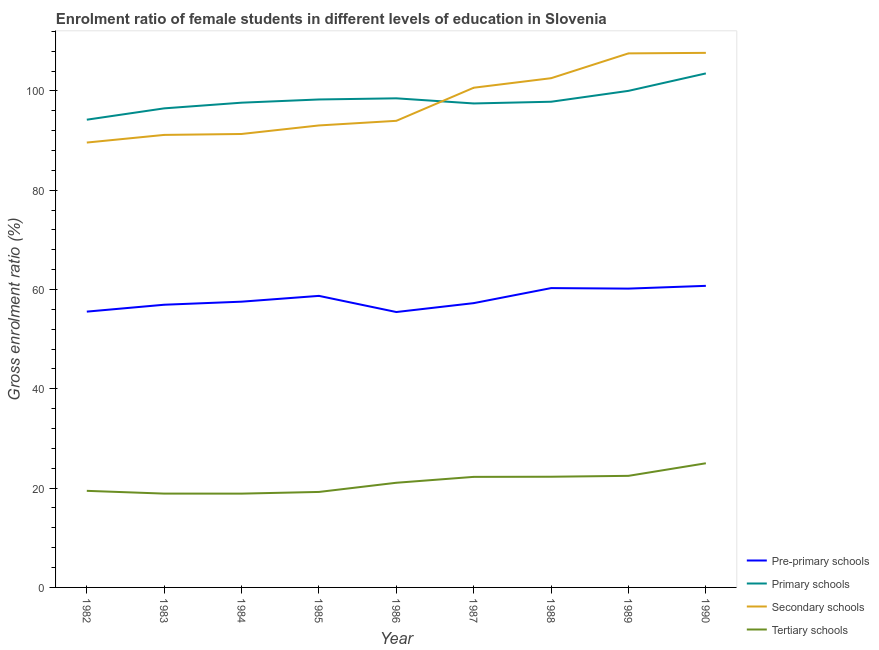Does the line corresponding to gross enrolment ratio(male) in secondary schools intersect with the line corresponding to gross enrolment ratio(male) in pre-primary schools?
Keep it short and to the point. No. What is the gross enrolment ratio(male) in secondary schools in 1986?
Your answer should be very brief. 93.98. Across all years, what is the maximum gross enrolment ratio(male) in pre-primary schools?
Your answer should be very brief. 60.74. Across all years, what is the minimum gross enrolment ratio(male) in secondary schools?
Keep it short and to the point. 89.61. In which year was the gross enrolment ratio(male) in pre-primary schools minimum?
Keep it short and to the point. 1986. What is the total gross enrolment ratio(male) in primary schools in the graph?
Provide a succinct answer. 884.01. What is the difference between the gross enrolment ratio(male) in pre-primary schools in 1987 and that in 1990?
Make the answer very short. -3.48. What is the difference between the gross enrolment ratio(male) in secondary schools in 1984 and the gross enrolment ratio(male) in pre-primary schools in 1986?
Provide a succinct answer. 35.86. What is the average gross enrolment ratio(male) in primary schools per year?
Your answer should be compact. 98.22. In the year 1987, what is the difference between the gross enrolment ratio(male) in tertiary schools and gross enrolment ratio(male) in primary schools?
Give a very brief answer. -75.21. In how many years, is the gross enrolment ratio(male) in primary schools greater than 104 %?
Ensure brevity in your answer.  0. What is the ratio of the gross enrolment ratio(male) in secondary schools in 1982 to that in 1984?
Your answer should be very brief. 0.98. What is the difference between the highest and the second highest gross enrolment ratio(male) in pre-primary schools?
Offer a very short reply. 0.45. What is the difference between the highest and the lowest gross enrolment ratio(male) in primary schools?
Your answer should be compact. 9.32. In how many years, is the gross enrolment ratio(male) in tertiary schools greater than the average gross enrolment ratio(male) in tertiary schools taken over all years?
Offer a very short reply. 5. Is the gross enrolment ratio(male) in tertiary schools strictly greater than the gross enrolment ratio(male) in primary schools over the years?
Make the answer very short. No. How many lines are there?
Provide a short and direct response. 4. What is the difference between two consecutive major ticks on the Y-axis?
Provide a short and direct response. 20. Does the graph contain grids?
Offer a terse response. No. How many legend labels are there?
Your response must be concise. 4. How are the legend labels stacked?
Keep it short and to the point. Vertical. What is the title of the graph?
Your answer should be compact. Enrolment ratio of female students in different levels of education in Slovenia. What is the label or title of the X-axis?
Provide a short and direct response. Year. What is the label or title of the Y-axis?
Offer a very short reply. Gross enrolment ratio (%). What is the Gross enrolment ratio (%) in Pre-primary schools in 1982?
Your response must be concise. 55.55. What is the Gross enrolment ratio (%) in Primary schools in 1982?
Offer a very short reply. 94.21. What is the Gross enrolment ratio (%) of Secondary schools in 1982?
Provide a succinct answer. 89.61. What is the Gross enrolment ratio (%) in Tertiary schools in 1982?
Offer a terse response. 19.45. What is the Gross enrolment ratio (%) in Pre-primary schools in 1983?
Offer a terse response. 56.94. What is the Gross enrolment ratio (%) of Primary schools in 1983?
Your answer should be very brief. 96.49. What is the Gross enrolment ratio (%) in Secondary schools in 1983?
Offer a terse response. 91.15. What is the Gross enrolment ratio (%) in Tertiary schools in 1983?
Keep it short and to the point. 18.9. What is the Gross enrolment ratio (%) in Pre-primary schools in 1984?
Your response must be concise. 57.56. What is the Gross enrolment ratio (%) in Primary schools in 1984?
Provide a short and direct response. 97.64. What is the Gross enrolment ratio (%) in Secondary schools in 1984?
Ensure brevity in your answer.  91.33. What is the Gross enrolment ratio (%) of Tertiary schools in 1984?
Offer a terse response. 18.89. What is the Gross enrolment ratio (%) of Pre-primary schools in 1985?
Offer a very short reply. 58.72. What is the Gross enrolment ratio (%) of Primary schools in 1985?
Offer a very short reply. 98.28. What is the Gross enrolment ratio (%) of Secondary schools in 1985?
Give a very brief answer. 93.05. What is the Gross enrolment ratio (%) of Tertiary schools in 1985?
Offer a very short reply. 19.23. What is the Gross enrolment ratio (%) of Pre-primary schools in 1986?
Keep it short and to the point. 55.47. What is the Gross enrolment ratio (%) of Primary schools in 1986?
Ensure brevity in your answer.  98.52. What is the Gross enrolment ratio (%) of Secondary schools in 1986?
Offer a terse response. 93.98. What is the Gross enrolment ratio (%) of Tertiary schools in 1986?
Offer a terse response. 21.08. What is the Gross enrolment ratio (%) in Pre-primary schools in 1987?
Your response must be concise. 57.26. What is the Gross enrolment ratio (%) in Primary schools in 1987?
Give a very brief answer. 97.48. What is the Gross enrolment ratio (%) of Secondary schools in 1987?
Give a very brief answer. 100.65. What is the Gross enrolment ratio (%) of Tertiary schools in 1987?
Make the answer very short. 22.27. What is the Gross enrolment ratio (%) of Pre-primary schools in 1988?
Your answer should be very brief. 60.29. What is the Gross enrolment ratio (%) in Primary schools in 1988?
Keep it short and to the point. 97.83. What is the Gross enrolment ratio (%) in Secondary schools in 1988?
Your response must be concise. 102.57. What is the Gross enrolment ratio (%) in Tertiary schools in 1988?
Your answer should be compact. 22.29. What is the Gross enrolment ratio (%) of Pre-primary schools in 1989?
Offer a very short reply. 60.19. What is the Gross enrolment ratio (%) in Primary schools in 1989?
Your answer should be compact. 100.02. What is the Gross enrolment ratio (%) in Secondary schools in 1989?
Your answer should be compact. 107.57. What is the Gross enrolment ratio (%) in Tertiary schools in 1989?
Offer a very short reply. 22.48. What is the Gross enrolment ratio (%) in Pre-primary schools in 1990?
Ensure brevity in your answer.  60.74. What is the Gross enrolment ratio (%) of Primary schools in 1990?
Ensure brevity in your answer.  103.53. What is the Gross enrolment ratio (%) in Secondary schools in 1990?
Give a very brief answer. 107.67. What is the Gross enrolment ratio (%) of Tertiary schools in 1990?
Give a very brief answer. 25.01. Across all years, what is the maximum Gross enrolment ratio (%) in Pre-primary schools?
Offer a terse response. 60.74. Across all years, what is the maximum Gross enrolment ratio (%) in Primary schools?
Offer a terse response. 103.53. Across all years, what is the maximum Gross enrolment ratio (%) in Secondary schools?
Provide a short and direct response. 107.67. Across all years, what is the maximum Gross enrolment ratio (%) in Tertiary schools?
Offer a very short reply. 25.01. Across all years, what is the minimum Gross enrolment ratio (%) of Pre-primary schools?
Your answer should be very brief. 55.47. Across all years, what is the minimum Gross enrolment ratio (%) of Primary schools?
Your answer should be very brief. 94.21. Across all years, what is the minimum Gross enrolment ratio (%) of Secondary schools?
Offer a very short reply. 89.61. Across all years, what is the minimum Gross enrolment ratio (%) in Tertiary schools?
Offer a terse response. 18.89. What is the total Gross enrolment ratio (%) of Pre-primary schools in the graph?
Ensure brevity in your answer.  522.73. What is the total Gross enrolment ratio (%) in Primary schools in the graph?
Your response must be concise. 884.01. What is the total Gross enrolment ratio (%) of Secondary schools in the graph?
Keep it short and to the point. 877.59. What is the total Gross enrolment ratio (%) in Tertiary schools in the graph?
Provide a succinct answer. 189.61. What is the difference between the Gross enrolment ratio (%) in Pre-primary schools in 1982 and that in 1983?
Keep it short and to the point. -1.39. What is the difference between the Gross enrolment ratio (%) of Primary schools in 1982 and that in 1983?
Keep it short and to the point. -2.28. What is the difference between the Gross enrolment ratio (%) of Secondary schools in 1982 and that in 1983?
Offer a very short reply. -1.54. What is the difference between the Gross enrolment ratio (%) in Tertiary schools in 1982 and that in 1983?
Ensure brevity in your answer.  0.56. What is the difference between the Gross enrolment ratio (%) of Pre-primary schools in 1982 and that in 1984?
Offer a terse response. -2. What is the difference between the Gross enrolment ratio (%) of Primary schools in 1982 and that in 1984?
Provide a succinct answer. -3.43. What is the difference between the Gross enrolment ratio (%) of Secondary schools in 1982 and that in 1984?
Your answer should be compact. -1.73. What is the difference between the Gross enrolment ratio (%) of Tertiary schools in 1982 and that in 1984?
Provide a succinct answer. 0.56. What is the difference between the Gross enrolment ratio (%) in Pre-primary schools in 1982 and that in 1985?
Provide a succinct answer. -3.17. What is the difference between the Gross enrolment ratio (%) in Primary schools in 1982 and that in 1985?
Your answer should be compact. -4.07. What is the difference between the Gross enrolment ratio (%) of Secondary schools in 1982 and that in 1985?
Ensure brevity in your answer.  -3.45. What is the difference between the Gross enrolment ratio (%) of Tertiary schools in 1982 and that in 1985?
Your response must be concise. 0.22. What is the difference between the Gross enrolment ratio (%) in Pre-primary schools in 1982 and that in 1986?
Make the answer very short. 0.08. What is the difference between the Gross enrolment ratio (%) of Primary schools in 1982 and that in 1986?
Your answer should be very brief. -4.3. What is the difference between the Gross enrolment ratio (%) in Secondary schools in 1982 and that in 1986?
Ensure brevity in your answer.  -4.38. What is the difference between the Gross enrolment ratio (%) of Tertiary schools in 1982 and that in 1986?
Make the answer very short. -1.63. What is the difference between the Gross enrolment ratio (%) in Pre-primary schools in 1982 and that in 1987?
Keep it short and to the point. -1.71. What is the difference between the Gross enrolment ratio (%) in Primary schools in 1982 and that in 1987?
Offer a very short reply. -3.27. What is the difference between the Gross enrolment ratio (%) of Secondary schools in 1982 and that in 1987?
Your answer should be very brief. -11.04. What is the difference between the Gross enrolment ratio (%) of Tertiary schools in 1982 and that in 1987?
Make the answer very short. -2.82. What is the difference between the Gross enrolment ratio (%) in Pre-primary schools in 1982 and that in 1988?
Your response must be concise. -4.74. What is the difference between the Gross enrolment ratio (%) of Primary schools in 1982 and that in 1988?
Keep it short and to the point. -3.62. What is the difference between the Gross enrolment ratio (%) of Secondary schools in 1982 and that in 1988?
Your response must be concise. -12.96. What is the difference between the Gross enrolment ratio (%) in Tertiary schools in 1982 and that in 1988?
Your response must be concise. -2.84. What is the difference between the Gross enrolment ratio (%) in Pre-primary schools in 1982 and that in 1989?
Provide a succinct answer. -4.63. What is the difference between the Gross enrolment ratio (%) in Primary schools in 1982 and that in 1989?
Offer a terse response. -5.81. What is the difference between the Gross enrolment ratio (%) in Secondary schools in 1982 and that in 1989?
Ensure brevity in your answer.  -17.96. What is the difference between the Gross enrolment ratio (%) of Tertiary schools in 1982 and that in 1989?
Your answer should be compact. -3.02. What is the difference between the Gross enrolment ratio (%) of Pre-primary schools in 1982 and that in 1990?
Provide a short and direct response. -5.19. What is the difference between the Gross enrolment ratio (%) of Primary schools in 1982 and that in 1990?
Provide a short and direct response. -9.32. What is the difference between the Gross enrolment ratio (%) of Secondary schools in 1982 and that in 1990?
Your response must be concise. -18.07. What is the difference between the Gross enrolment ratio (%) of Tertiary schools in 1982 and that in 1990?
Offer a very short reply. -5.56. What is the difference between the Gross enrolment ratio (%) of Pre-primary schools in 1983 and that in 1984?
Make the answer very short. -0.62. What is the difference between the Gross enrolment ratio (%) in Primary schools in 1983 and that in 1984?
Your answer should be very brief. -1.14. What is the difference between the Gross enrolment ratio (%) of Secondary schools in 1983 and that in 1984?
Ensure brevity in your answer.  -0.19. What is the difference between the Gross enrolment ratio (%) in Tertiary schools in 1983 and that in 1984?
Give a very brief answer. 0. What is the difference between the Gross enrolment ratio (%) of Pre-primary schools in 1983 and that in 1985?
Keep it short and to the point. -1.78. What is the difference between the Gross enrolment ratio (%) in Primary schools in 1983 and that in 1985?
Make the answer very short. -1.79. What is the difference between the Gross enrolment ratio (%) in Secondary schools in 1983 and that in 1985?
Your answer should be very brief. -1.91. What is the difference between the Gross enrolment ratio (%) of Tertiary schools in 1983 and that in 1985?
Make the answer very short. -0.33. What is the difference between the Gross enrolment ratio (%) in Pre-primary schools in 1983 and that in 1986?
Provide a succinct answer. 1.47. What is the difference between the Gross enrolment ratio (%) in Primary schools in 1983 and that in 1986?
Make the answer very short. -2.02. What is the difference between the Gross enrolment ratio (%) of Secondary schools in 1983 and that in 1986?
Offer a very short reply. -2.84. What is the difference between the Gross enrolment ratio (%) in Tertiary schools in 1983 and that in 1986?
Give a very brief answer. -2.18. What is the difference between the Gross enrolment ratio (%) of Pre-primary schools in 1983 and that in 1987?
Give a very brief answer. -0.32. What is the difference between the Gross enrolment ratio (%) in Primary schools in 1983 and that in 1987?
Your answer should be very brief. -0.99. What is the difference between the Gross enrolment ratio (%) of Secondary schools in 1983 and that in 1987?
Your answer should be very brief. -9.5. What is the difference between the Gross enrolment ratio (%) of Tertiary schools in 1983 and that in 1987?
Offer a terse response. -3.37. What is the difference between the Gross enrolment ratio (%) of Pre-primary schools in 1983 and that in 1988?
Ensure brevity in your answer.  -3.35. What is the difference between the Gross enrolment ratio (%) of Primary schools in 1983 and that in 1988?
Provide a short and direct response. -1.33. What is the difference between the Gross enrolment ratio (%) in Secondary schools in 1983 and that in 1988?
Ensure brevity in your answer.  -11.42. What is the difference between the Gross enrolment ratio (%) of Tertiary schools in 1983 and that in 1988?
Provide a short and direct response. -3.4. What is the difference between the Gross enrolment ratio (%) in Pre-primary schools in 1983 and that in 1989?
Provide a short and direct response. -3.25. What is the difference between the Gross enrolment ratio (%) of Primary schools in 1983 and that in 1989?
Offer a terse response. -3.53. What is the difference between the Gross enrolment ratio (%) in Secondary schools in 1983 and that in 1989?
Make the answer very short. -16.42. What is the difference between the Gross enrolment ratio (%) in Tertiary schools in 1983 and that in 1989?
Offer a very short reply. -3.58. What is the difference between the Gross enrolment ratio (%) of Pre-primary schools in 1983 and that in 1990?
Give a very brief answer. -3.8. What is the difference between the Gross enrolment ratio (%) in Primary schools in 1983 and that in 1990?
Your answer should be very brief. -7.04. What is the difference between the Gross enrolment ratio (%) of Secondary schools in 1983 and that in 1990?
Your answer should be compact. -16.53. What is the difference between the Gross enrolment ratio (%) in Tertiary schools in 1983 and that in 1990?
Provide a succinct answer. -6.11. What is the difference between the Gross enrolment ratio (%) of Pre-primary schools in 1984 and that in 1985?
Make the answer very short. -1.17. What is the difference between the Gross enrolment ratio (%) in Primary schools in 1984 and that in 1985?
Provide a succinct answer. -0.65. What is the difference between the Gross enrolment ratio (%) in Secondary schools in 1984 and that in 1985?
Provide a short and direct response. -1.72. What is the difference between the Gross enrolment ratio (%) in Tertiary schools in 1984 and that in 1985?
Make the answer very short. -0.34. What is the difference between the Gross enrolment ratio (%) of Pre-primary schools in 1984 and that in 1986?
Your answer should be compact. 2.08. What is the difference between the Gross enrolment ratio (%) of Primary schools in 1984 and that in 1986?
Offer a very short reply. -0.88. What is the difference between the Gross enrolment ratio (%) in Secondary schools in 1984 and that in 1986?
Give a very brief answer. -2.65. What is the difference between the Gross enrolment ratio (%) of Tertiary schools in 1984 and that in 1986?
Offer a terse response. -2.19. What is the difference between the Gross enrolment ratio (%) in Pre-primary schools in 1984 and that in 1987?
Make the answer very short. 0.29. What is the difference between the Gross enrolment ratio (%) of Primary schools in 1984 and that in 1987?
Offer a very short reply. 0.16. What is the difference between the Gross enrolment ratio (%) of Secondary schools in 1984 and that in 1987?
Give a very brief answer. -9.32. What is the difference between the Gross enrolment ratio (%) of Tertiary schools in 1984 and that in 1987?
Keep it short and to the point. -3.37. What is the difference between the Gross enrolment ratio (%) of Pre-primary schools in 1984 and that in 1988?
Offer a very short reply. -2.73. What is the difference between the Gross enrolment ratio (%) in Primary schools in 1984 and that in 1988?
Provide a short and direct response. -0.19. What is the difference between the Gross enrolment ratio (%) of Secondary schools in 1984 and that in 1988?
Offer a terse response. -11.24. What is the difference between the Gross enrolment ratio (%) of Tertiary schools in 1984 and that in 1988?
Your answer should be compact. -3.4. What is the difference between the Gross enrolment ratio (%) of Pre-primary schools in 1984 and that in 1989?
Offer a very short reply. -2.63. What is the difference between the Gross enrolment ratio (%) of Primary schools in 1984 and that in 1989?
Your answer should be compact. -2.38. What is the difference between the Gross enrolment ratio (%) of Secondary schools in 1984 and that in 1989?
Make the answer very short. -16.23. What is the difference between the Gross enrolment ratio (%) in Tertiary schools in 1984 and that in 1989?
Your response must be concise. -3.58. What is the difference between the Gross enrolment ratio (%) in Pre-primary schools in 1984 and that in 1990?
Provide a short and direct response. -3.19. What is the difference between the Gross enrolment ratio (%) in Primary schools in 1984 and that in 1990?
Your answer should be very brief. -5.89. What is the difference between the Gross enrolment ratio (%) in Secondary schools in 1984 and that in 1990?
Your answer should be compact. -16.34. What is the difference between the Gross enrolment ratio (%) of Tertiary schools in 1984 and that in 1990?
Make the answer very short. -6.12. What is the difference between the Gross enrolment ratio (%) of Pre-primary schools in 1985 and that in 1986?
Provide a succinct answer. 3.25. What is the difference between the Gross enrolment ratio (%) in Primary schools in 1985 and that in 1986?
Offer a very short reply. -0.23. What is the difference between the Gross enrolment ratio (%) of Secondary schools in 1985 and that in 1986?
Provide a succinct answer. -0.93. What is the difference between the Gross enrolment ratio (%) in Tertiary schools in 1985 and that in 1986?
Offer a very short reply. -1.85. What is the difference between the Gross enrolment ratio (%) in Pre-primary schools in 1985 and that in 1987?
Offer a terse response. 1.46. What is the difference between the Gross enrolment ratio (%) in Primary schools in 1985 and that in 1987?
Make the answer very short. 0.8. What is the difference between the Gross enrolment ratio (%) in Secondary schools in 1985 and that in 1987?
Offer a very short reply. -7.6. What is the difference between the Gross enrolment ratio (%) of Tertiary schools in 1985 and that in 1987?
Offer a terse response. -3.04. What is the difference between the Gross enrolment ratio (%) of Pre-primary schools in 1985 and that in 1988?
Give a very brief answer. -1.57. What is the difference between the Gross enrolment ratio (%) in Primary schools in 1985 and that in 1988?
Make the answer very short. 0.46. What is the difference between the Gross enrolment ratio (%) of Secondary schools in 1985 and that in 1988?
Your answer should be compact. -9.52. What is the difference between the Gross enrolment ratio (%) in Tertiary schools in 1985 and that in 1988?
Make the answer very short. -3.06. What is the difference between the Gross enrolment ratio (%) in Pre-primary schools in 1985 and that in 1989?
Your answer should be compact. -1.46. What is the difference between the Gross enrolment ratio (%) in Primary schools in 1985 and that in 1989?
Offer a very short reply. -1.74. What is the difference between the Gross enrolment ratio (%) of Secondary schools in 1985 and that in 1989?
Give a very brief answer. -14.52. What is the difference between the Gross enrolment ratio (%) in Tertiary schools in 1985 and that in 1989?
Offer a very short reply. -3.24. What is the difference between the Gross enrolment ratio (%) in Pre-primary schools in 1985 and that in 1990?
Your response must be concise. -2.02. What is the difference between the Gross enrolment ratio (%) in Primary schools in 1985 and that in 1990?
Your answer should be compact. -5.25. What is the difference between the Gross enrolment ratio (%) in Secondary schools in 1985 and that in 1990?
Make the answer very short. -14.62. What is the difference between the Gross enrolment ratio (%) of Tertiary schools in 1985 and that in 1990?
Keep it short and to the point. -5.78. What is the difference between the Gross enrolment ratio (%) of Pre-primary schools in 1986 and that in 1987?
Give a very brief answer. -1.79. What is the difference between the Gross enrolment ratio (%) in Primary schools in 1986 and that in 1987?
Your answer should be very brief. 1.03. What is the difference between the Gross enrolment ratio (%) in Secondary schools in 1986 and that in 1987?
Keep it short and to the point. -6.67. What is the difference between the Gross enrolment ratio (%) in Tertiary schools in 1986 and that in 1987?
Provide a succinct answer. -1.19. What is the difference between the Gross enrolment ratio (%) of Pre-primary schools in 1986 and that in 1988?
Your response must be concise. -4.82. What is the difference between the Gross enrolment ratio (%) of Primary schools in 1986 and that in 1988?
Provide a succinct answer. 0.69. What is the difference between the Gross enrolment ratio (%) in Secondary schools in 1986 and that in 1988?
Provide a short and direct response. -8.59. What is the difference between the Gross enrolment ratio (%) of Tertiary schools in 1986 and that in 1988?
Make the answer very short. -1.21. What is the difference between the Gross enrolment ratio (%) of Pre-primary schools in 1986 and that in 1989?
Provide a succinct answer. -4.71. What is the difference between the Gross enrolment ratio (%) in Primary schools in 1986 and that in 1989?
Keep it short and to the point. -1.51. What is the difference between the Gross enrolment ratio (%) of Secondary schools in 1986 and that in 1989?
Your answer should be very brief. -13.58. What is the difference between the Gross enrolment ratio (%) in Tertiary schools in 1986 and that in 1989?
Your response must be concise. -1.39. What is the difference between the Gross enrolment ratio (%) in Pre-primary schools in 1986 and that in 1990?
Make the answer very short. -5.27. What is the difference between the Gross enrolment ratio (%) in Primary schools in 1986 and that in 1990?
Your answer should be very brief. -5.02. What is the difference between the Gross enrolment ratio (%) in Secondary schools in 1986 and that in 1990?
Offer a very short reply. -13.69. What is the difference between the Gross enrolment ratio (%) of Tertiary schools in 1986 and that in 1990?
Offer a very short reply. -3.93. What is the difference between the Gross enrolment ratio (%) of Pre-primary schools in 1987 and that in 1988?
Offer a terse response. -3.03. What is the difference between the Gross enrolment ratio (%) of Primary schools in 1987 and that in 1988?
Make the answer very short. -0.35. What is the difference between the Gross enrolment ratio (%) in Secondary schools in 1987 and that in 1988?
Offer a terse response. -1.92. What is the difference between the Gross enrolment ratio (%) in Tertiary schools in 1987 and that in 1988?
Keep it short and to the point. -0.03. What is the difference between the Gross enrolment ratio (%) in Pre-primary schools in 1987 and that in 1989?
Make the answer very short. -2.92. What is the difference between the Gross enrolment ratio (%) in Primary schools in 1987 and that in 1989?
Your answer should be compact. -2.54. What is the difference between the Gross enrolment ratio (%) of Secondary schools in 1987 and that in 1989?
Ensure brevity in your answer.  -6.92. What is the difference between the Gross enrolment ratio (%) in Tertiary schools in 1987 and that in 1989?
Ensure brevity in your answer.  -0.21. What is the difference between the Gross enrolment ratio (%) of Pre-primary schools in 1987 and that in 1990?
Offer a very short reply. -3.48. What is the difference between the Gross enrolment ratio (%) in Primary schools in 1987 and that in 1990?
Offer a very short reply. -6.05. What is the difference between the Gross enrolment ratio (%) of Secondary schools in 1987 and that in 1990?
Provide a succinct answer. -7.02. What is the difference between the Gross enrolment ratio (%) in Tertiary schools in 1987 and that in 1990?
Give a very brief answer. -2.74. What is the difference between the Gross enrolment ratio (%) of Pre-primary schools in 1988 and that in 1989?
Keep it short and to the point. 0.1. What is the difference between the Gross enrolment ratio (%) of Primary schools in 1988 and that in 1989?
Offer a terse response. -2.19. What is the difference between the Gross enrolment ratio (%) of Secondary schools in 1988 and that in 1989?
Your response must be concise. -5. What is the difference between the Gross enrolment ratio (%) of Tertiary schools in 1988 and that in 1989?
Your answer should be very brief. -0.18. What is the difference between the Gross enrolment ratio (%) in Pre-primary schools in 1988 and that in 1990?
Give a very brief answer. -0.45. What is the difference between the Gross enrolment ratio (%) of Primary schools in 1988 and that in 1990?
Keep it short and to the point. -5.71. What is the difference between the Gross enrolment ratio (%) in Secondary schools in 1988 and that in 1990?
Your answer should be very brief. -5.1. What is the difference between the Gross enrolment ratio (%) of Tertiary schools in 1988 and that in 1990?
Offer a terse response. -2.71. What is the difference between the Gross enrolment ratio (%) of Pre-primary schools in 1989 and that in 1990?
Offer a very short reply. -0.56. What is the difference between the Gross enrolment ratio (%) in Primary schools in 1989 and that in 1990?
Offer a very short reply. -3.51. What is the difference between the Gross enrolment ratio (%) in Secondary schools in 1989 and that in 1990?
Ensure brevity in your answer.  -0.1. What is the difference between the Gross enrolment ratio (%) of Tertiary schools in 1989 and that in 1990?
Provide a succinct answer. -2.53. What is the difference between the Gross enrolment ratio (%) in Pre-primary schools in 1982 and the Gross enrolment ratio (%) in Primary schools in 1983?
Offer a terse response. -40.94. What is the difference between the Gross enrolment ratio (%) of Pre-primary schools in 1982 and the Gross enrolment ratio (%) of Secondary schools in 1983?
Offer a terse response. -35.59. What is the difference between the Gross enrolment ratio (%) of Pre-primary schools in 1982 and the Gross enrolment ratio (%) of Tertiary schools in 1983?
Offer a very short reply. 36.65. What is the difference between the Gross enrolment ratio (%) of Primary schools in 1982 and the Gross enrolment ratio (%) of Secondary schools in 1983?
Your response must be concise. 3.06. What is the difference between the Gross enrolment ratio (%) of Primary schools in 1982 and the Gross enrolment ratio (%) of Tertiary schools in 1983?
Offer a very short reply. 75.31. What is the difference between the Gross enrolment ratio (%) of Secondary schools in 1982 and the Gross enrolment ratio (%) of Tertiary schools in 1983?
Give a very brief answer. 70.71. What is the difference between the Gross enrolment ratio (%) in Pre-primary schools in 1982 and the Gross enrolment ratio (%) in Primary schools in 1984?
Provide a short and direct response. -42.09. What is the difference between the Gross enrolment ratio (%) of Pre-primary schools in 1982 and the Gross enrolment ratio (%) of Secondary schools in 1984?
Give a very brief answer. -35.78. What is the difference between the Gross enrolment ratio (%) in Pre-primary schools in 1982 and the Gross enrolment ratio (%) in Tertiary schools in 1984?
Your answer should be compact. 36.66. What is the difference between the Gross enrolment ratio (%) in Primary schools in 1982 and the Gross enrolment ratio (%) in Secondary schools in 1984?
Ensure brevity in your answer.  2.88. What is the difference between the Gross enrolment ratio (%) in Primary schools in 1982 and the Gross enrolment ratio (%) in Tertiary schools in 1984?
Provide a succinct answer. 75.32. What is the difference between the Gross enrolment ratio (%) in Secondary schools in 1982 and the Gross enrolment ratio (%) in Tertiary schools in 1984?
Make the answer very short. 70.71. What is the difference between the Gross enrolment ratio (%) in Pre-primary schools in 1982 and the Gross enrolment ratio (%) in Primary schools in 1985?
Your answer should be very brief. -42.73. What is the difference between the Gross enrolment ratio (%) of Pre-primary schools in 1982 and the Gross enrolment ratio (%) of Secondary schools in 1985?
Ensure brevity in your answer.  -37.5. What is the difference between the Gross enrolment ratio (%) of Pre-primary schools in 1982 and the Gross enrolment ratio (%) of Tertiary schools in 1985?
Offer a terse response. 36.32. What is the difference between the Gross enrolment ratio (%) of Primary schools in 1982 and the Gross enrolment ratio (%) of Secondary schools in 1985?
Provide a succinct answer. 1.16. What is the difference between the Gross enrolment ratio (%) of Primary schools in 1982 and the Gross enrolment ratio (%) of Tertiary schools in 1985?
Give a very brief answer. 74.98. What is the difference between the Gross enrolment ratio (%) in Secondary schools in 1982 and the Gross enrolment ratio (%) in Tertiary schools in 1985?
Your answer should be very brief. 70.37. What is the difference between the Gross enrolment ratio (%) of Pre-primary schools in 1982 and the Gross enrolment ratio (%) of Primary schools in 1986?
Provide a succinct answer. -42.96. What is the difference between the Gross enrolment ratio (%) of Pre-primary schools in 1982 and the Gross enrolment ratio (%) of Secondary schools in 1986?
Give a very brief answer. -38.43. What is the difference between the Gross enrolment ratio (%) in Pre-primary schools in 1982 and the Gross enrolment ratio (%) in Tertiary schools in 1986?
Keep it short and to the point. 34.47. What is the difference between the Gross enrolment ratio (%) in Primary schools in 1982 and the Gross enrolment ratio (%) in Secondary schools in 1986?
Give a very brief answer. 0.23. What is the difference between the Gross enrolment ratio (%) of Primary schools in 1982 and the Gross enrolment ratio (%) of Tertiary schools in 1986?
Make the answer very short. 73.13. What is the difference between the Gross enrolment ratio (%) of Secondary schools in 1982 and the Gross enrolment ratio (%) of Tertiary schools in 1986?
Give a very brief answer. 68.53. What is the difference between the Gross enrolment ratio (%) of Pre-primary schools in 1982 and the Gross enrolment ratio (%) of Primary schools in 1987?
Give a very brief answer. -41.93. What is the difference between the Gross enrolment ratio (%) in Pre-primary schools in 1982 and the Gross enrolment ratio (%) in Secondary schools in 1987?
Make the answer very short. -45.1. What is the difference between the Gross enrolment ratio (%) in Pre-primary schools in 1982 and the Gross enrolment ratio (%) in Tertiary schools in 1987?
Keep it short and to the point. 33.28. What is the difference between the Gross enrolment ratio (%) in Primary schools in 1982 and the Gross enrolment ratio (%) in Secondary schools in 1987?
Your answer should be compact. -6.44. What is the difference between the Gross enrolment ratio (%) in Primary schools in 1982 and the Gross enrolment ratio (%) in Tertiary schools in 1987?
Your answer should be compact. 71.94. What is the difference between the Gross enrolment ratio (%) in Secondary schools in 1982 and the Gross enrolment ratio (%) in Tertiary schools in 1987?
Offer a terse response. 67.34. What is the difference between the Gross enrolment ratio (%) in Pre-primary schools in 1982 and the Gross enrolment ratio (%) in Primary schools in 1988?
Make the answer very short. -42.27. What is the difference between the Gross enrolment ratio (%) of Pre-primary schools in 1982 and the Gross enrolment ratio (%) of Secondary schools in 1988?
Provide a short and direct response. -47.02. What is the difference between the Gross enrolment ratio (%) of Pre-primary schools in 1982 and the Gross enrolment ratio (%) of Tertiary schools in 1988?
Give a very brief answer. 33.26. What is the difference between the Gross enrolment ratio (%) of Primary schools in 1982 and the Gross enrolment ratio (%) of Secondary schools in 1988?
Offer a very short reply. -8.36. What is the difference between the Gross enrolment ratio (%) of Primary schools in 1982 and the Gross enrolment ratio (%) of Tertiary schools in 1988?
Make the answer very short. 71.92. What is the difference between the Gross enrolment ratio (%) in Secondary schools in 1982 and the Gross enrolment ratio (%) in Tertiary schools in 1988?
Provide a succinct answer. 67.31. What is the difference between the Gross enrolment ratio (%) of Pre-primary schools in 1982 and the Gross enrolment ratio (%) of Primary schools in 1989?
Offer a very short reply. -44.47. What is the difference between the Gross enrolment ratio (%) of Pre-primary schools in 1982 and the Gross enrolment ratio (%) of Secondary schools in 1989?
Keep it short and to the point. -52.02. What is the difference between the Gross enrolment ratio (%) in Pre-primary schools in 1982 and the Gross enrolment ratio (%) in Tertiary schools in 1989?
Give a very brief answer. 33.08. What is the difference between the Gross enrolment ratio (%) of Primary schools in 1982 and the Gross enrolment ratio (%) of Secondary schools in 1989?
Ensure brevity in your answer.  -13.36. What is the difference between the Gross enrolment ratio (%) in Primary schools in 1982 and the Gross enrolment ratio (%) in Tertiary schools in 1989?
Give a very brief answer. 71.74. What is the difference between the Gross enrolment ratio (%) in Secondary schools in 1982 and the Gross enrolment ratio (%) in Tertiary schools in 1989?
Your response must be concise. 67.13. What is the difference between the Gross enrolment ratio (%) in Pre-primary schools in 1982 and the Gross enrolment ratio (%) in Primary schools in 1990?
Give a very brief answer. -47.98. What is the difference between the Gross enrolment ratio (%) in Pre-primary schools in 1982 and the Gross enrolment ratio (%) in Secondary schools in 1990?
Offer a very short reply. -52.12. What is the difference between the Gross enrolment ratio (%) of Pre-primary schools in 1982 and the Gross enrolment ratio (%) of Tertiary schools in 1990?
Your answer should be very brief. 30.54. What is the difference between the Gross enrolment ratio (%) of Primary schools in 1982 and the Gross enrolment ratio (%) of Secondary schools in 1990?
Offer a terse response. -13.46. What is the difference between the Gross enrolment ratio (%) in Primary schools in 1982 and the Gross enrolment ratio (%) in Tertiary schools in 1990?
Offer a terse response. 69.2. What is the difference between the Gross enrolment ratio (%) in Secondary schools in 1982 and the Gross enrolment ratio (%) in Tertiary schools in 1990?
Your answer should be very brief. 64.6. What is the difference between the Gross enrolment ratio (%) of Pre-primary schools in 1983 and the Gross enrolment ratio (%) of Primary schools in 1984?
Give a very brief answer. -40.7. What is the difference between the Gross enrolment ratio (%) in Pre-primary schools in 1983 and the Gross enrolment ratio (%) in Secondary schools in 1984?
Your answer should be very brief. -34.39. What is the difference between the Gross enrolment ratio (%) in Pre-primary schools in 1983 and the Gross enrolment ratio (%) in Tertiary schools in 1984?
Ensure brevity in your answer.  38.05. What is the difference between the Gross enrolment ratio (%) of Primary schools in 1983 and the Gross enrolment ratio (%) of Secondary schools in 1984?
Your answer should be compact. 5.16. What is the difference between the Gross enrolment ratio (%) of Primary schools in 1983 and the Gross enrolment ratio (%) of Tertiary schools in 1984?
Your answer should be very brief. 77.6. What is the difference between the Gross enrolment ratio (%) of Secondary schools in 1983 and the Gross enrolment ratio (%) of Tertiary schools in 1984?
Your answer should be compact. 72.25. What is the difference between the Gross enrolment ratio (%) of Pre-primary schools in 1983 and the Gross enrolment ratio (%) of Primary schools in 1985?
Offer a terse response. -41.34. What is the difference between the Gross enrolment ratio (%) of Pre-primary schools in 1983 and the Gross enrolment ratio (%) of Secondary schools in 1985?
Your answer should be very brief. -36.11. What is the difference between the Gross enrolment ratio (%) of Pre-primary schools in 1983 and the Gross enrolment ratio (%) of Tertiary schools in 1985?
Your answer should be very brief. 37.71. What is the difference between the Gross enrolment ratio (%) of Primary schools in 1983 and the Gross enrolment ratio (%) of Secondary schools in 1985?
Provide a short and direct response. 3.44. What is the difference between the Gross enrolment ratio (%) of Primary schools in 1983 and the Gross enrolment ratio (%) of Tertiary schools in 1985?
Provide a succinct answer. 77.26. What is the difference between the Gross enrolment ratio (%) of Secondary schools in 1983 and the Gross enrolment ratio (%) of Tertiary schools in 1985?
Offer a very short reply. 71.92. What is the difference between the Gross enrolment ratio (%) of Pre-primary schools in 1983 and the Gross enrolment ratio (%) of Primary schools in 1986?
Give a very brief answer. -41.57. What is the difference between the Gross enrolment ratio (%) of Pre-primary schools in 1983 and the Gross enrolment ratio (%) of Secondary schools in 1986?
Keep it short and to the point. -37.04. What is the difference between the Gross enrolment ratio (%) of Pre-primary schools in 1983 and the Gross enrolment ratio (%) of Tertiary schools in 1986?
Ensure brevity in your answer.  35.86. What is the difference between the Gross enrolment ratio (%) of Primary schools in 1983 and the Gross enrolment ratio (%) of Secondary schools in 1986?
Your response must be concise. 2.51. What is the difference between the Gross enrolment ratio (%) in Primary schools in 1983 and the Gross enrolment ratio (%) in Tertiary schools in 1986?
Provide a succinct answer. 75.41. What is the difference between the Gross enrolment ratio (%) of Secondary schools in 1983 and the Gross enrolment ratio (%) of Tertiary schools in 1986?
Keep it short and to the point. 70.07. What is the difference between the Gross enrolment ratio (%) in Pre-primary schools in 1983 and the Gross enrolment ratio (%) in Primary schools in 1987?
Your answer should be very brief. -40.54. What is the difference between the Gross enrolment ratio (%) of Pre-primary schools in 1983 and the Gross enrolment ratio (%) of Secondary schools in 1987?
Provide a short and direct response. -43.71. What is the difference between the Gross enrolment ratio (%) in Pre-primary schools in 1983 and the Gross enrolment ratio (%) in Tertiary schools in 1987?
Ensure brevity in your answer.  34.67. What is the difference between the Gross enrolment ratio (%) in Primary schools in 1983 and the Gross enrolment ratio (%) in Secondary schools in 1987?
Your answer should be compact. -4.16. What is the difference between the Gross enrolment ratio (%) in Primary schools in 1983 and the Gross enrolment ratio (%) in Tertiary schools in 1987?
Offer a terse response. 74.23. What is the difference between the Gross enrolment ratio (%) in Secondary schools in 1983 and the Gross enrolment ratio (%) in Tertiary schools in 1987?
Your response must be concise. 68.88. What is the difference between the Gross enrolment ratio (%) of Pre-primary schools in 1983 and the Gross enrolment ratio (%) of Primary schools in 1988?
Your answer should be very brief. -40.89. What is the difference between the Gross enrolment ratio (%) of Pre-primary schools in 1983 and the Gross enrolment ratio (%) of Secondary schools in 1988?
Offer a very short reply. -45.63. What is the difference between the Gross enrolment ratio (%) of Pre-primary schools in 1983 and the Gross enrolment ratio (%) of Tertiary schools in 1988?
Ensure brevity in your answer.  34.65. What is the difference between the Gross enrolment ratio (%) of Primary schools in 1983 and the Gross enrolment ratio (%) of Secondary schools in 1988?
Offer a terse response. -6.08. What is the difference between the Gross enrolment ratio (%) in Primary schools in 1983 and the Gross enrolment ratio (%) in Tertiary schools in 1988?
Your response must be concise. 74.2. What is the difference between the Gross enrolment ratio (%) of Secondary schools in 1983 and the Gross enrolment ratio (%) of Tertiary schools in 1988?
Keep it short and to the point. 68.85. What is the difference between the Gross enrolment ratio (%) of Pre-primary schools in 1983 and the Gross enrolment ratio (%) of Primary schools in 1989?
Make the answer very short. -43.08. What is the difference between the Gross enrolment ratio (%) in Pre-primary schools in 1983 and the Gross enrolment ratio (%) in Secondary schools in 1989?
Your response must be concise. -50.63. What is the difference between the Gross enrolment ratio (%) of Pre-primary schools in 1983 and the Gross enrolment ratio (%) of Tertiary schools in 1989?
Your answer should be compact. 34.47. What is the difference between the Gross enrolment ratio (%) in Primary schools in 1983 and the Gross enrolment ratio (%) in Secondary schools in 1989?
Your answer should be very brief. -11.07. What is the difference between the Gross enrolment ratio (%) in Primary schools in 1983 and the Gross enrolment ratio (%) in Tertiary schools in 1989?
Offer a very short reply. 74.02. What is the difference between the Gross enrolment ratio (%) in Secondary schools in 1983 and the Gross enrolment ratio (%) in Tertiary schools in 1989?
Make the answer very short. 68.67. What is the difference between the Gross enrolment ratio (%) in Pre-primary schools in 1983 and the Gross enrolment ratio (%) in Primary schools in 1990?
Provide a short and direct response. -46.59. What is the difference between the Gross enrolment ratio (%) of Pre-primary schools in 1983 and the Gross enrolment ratio (%) of Secondary schools in 1990?
Keep it short and to the point. -50.73. What is the difference between the Gross enrolment ratio (%) of Pre-primary schools in 1983 and the Gross enrolment ratio (%) of Tertiary schools in 1990?
Keep it short and to the point. 31.93. What is the difference between the Gross enrolment ratio (%) in Primary schools in 1983 and the Gross enrolment ratio (%) in Secondary schools in 1990?
Keep it short and to the point. -11.18. What is the difference between the Gross enrolment ratio (%) in Primary schools in 1983 and the Gross enrolment ratio (%) in Tertiary schools in 1990?
Ensure brevity in your answer.  71.49. What is the difference between the Gross enrolment ratio (%) of Secondary schools in 1983 and the Gross enrolment ratio (%) of Tertiary schools in 1990?
Your response must be concise. 66.14. What is the difference between the Gross enrolment ratio (%) in Pre-primary schools in 1984 and the Gross enrolment ratio (%) in Primary schools in 1985?
Make the answer very short. -40.73. What is the difference between the Gross enrolment ratio (%) of Pre-primary schools in 1984 and the Gross enrolment ratio (%) of Secondary schools in 1985?
Your response must be concise. -35.5. What is the difference between the Gross enrolment ratio (%) in Pre-primary schools in 1984 and the Gross enrolment ratio (%) in Tertiary schools in 1985?
Offer a terse response. 38.32. What is the difference between the Gross enrolment ratio (%) in Primary schools in 1984 and the Gross enrolment ratio (%) in Secondary schools in 1985?
Ensure brevity in your answer.  4.59. What is the difference between the Gross enrolment ratio (%) in Primary schools in 1984 and the Gross enrolment ratio (%) in Tertiary schools in 1985?
Your answer should be very brief. 78.41. What is the difference between the Gross enrolment ratio (%) of Secondary schools in 1984 and the Gross enrolment ratio (%) of Tertiary schools in 1985?
Provide a succinct answer. 72.1. What is the difference between the Gross enrolment ratio (%) in Pre-primary schools in 1984 and the Gross enrolment ratio (%) in Primary schools in 1986?
Your answer should be very brief. -40.96. What is the difference between the Gross enrolment ratio (%) of Pre-primary schools in 1984 and the Gross enrolment ratio (%) of Secondary schools in 1986?
Ensure brevity in your answer.  -36.43. What is the difference between the Gross enrolment ratio (%) in Pre-primary schools in 1984 and the Gross enrolment ratio (%) in Tertiary schools in 1986?
Offer a very short reply. 36.47. What is the difference between the Gross enrolment ratio (%) in Primary schools in 1984 and the Gross enrolment ratio (%) in Secondary schools in 1986?
Your answer should be compact. 3.65. What is the difference between the Gross enrolment ratio (%) of Primary schools in 1984 and the Gross enrolment ratio (%) of Tertiary schools in 1986?
Offer a very short reply. 76.56. What is the difference between the Gross enrolment ratio (%) in Secondary schools in 1984 and the Gross enrolment ratio (%) in Tertiary schools in 1986?
Ensure brevity in your answer.  70.25. What is the difference between the Gross enrolment ratio (%) in Pre-primary schools in 1984 and the Gross enrolment ratio (%) in Primary schools in 1987?
Keep it short and to the point. -39.93. What is the difference between the Gross enrolment ratio (%) of Pre-primary schools in 1984 and the Gross enrolment ratio (%) of Secondary schools in 1987?
Give a very brief answer. -43.09. What is the difference between the Gross enrolment ratio (%) in Pre-primary schools in 1984 and the Gross enrolment ratio (%) in Tertiary schools in 1987?
Your answer should be compact. 35.29. What is the difference between the Gross enrolment ratio (%) of Primary schools in 1984 and the Gross enrolment ratio (%) of Secondary schools in 1987?
Provide a succinct answer. -3.01. What is the difference between the Gross enrolment ratio (%) of Primary schools in 1984 and the Gross enrolment ratio (%) of Tertiary schools in 1987?
Offer a very short reply. 75.37. What is the difference between the Gross enrolment ratio (%) of Secondary schools in 1984 and the Gross enrolment ratio (%) of Tertiary schools in 1987?
Give a very brief answer. 69.07. What is the difference between the Gross enrolment ratio (%) in Pre-primary schools in 1984 and the Gross enrolment ratio (%) in Primary schools in 1988?
Your answer should be compact. -40.27. What is the difference between the Gross enrolment ratio (%) in Pre-primary schools in 1984 and the Gross enrolment ratio (%) in Secondary schools in 1988?
Provide a succinct answer. -45.01. What is the difference between the Gross enrolment ratio (%) in Pre-primary schools in 1984 and the Gross enrolment ratio (%) in Tertiary schools in 1988?
Offer a very short reply. 35.26. What is the difference between the Gross enrolment ratio (%) of Primary schools in 1984 and the Gross enrolment ratio (%) of Secondary schools in 1988?
Offer a very short reply. -4.93. What is the difference between the Gross enrolment ratio (%) of Primary schools in 1984 and the Gross enrolment ratio (%) of Tertiary schools in 1988?
Your response must be concise. 75.34. What is the difference between the Gross enrolment ratio (%) in Secondary schools in 1984 and the Gross enrolment ratio (%) in Tertiary schools in 1988?
Provide a short and direct response. 69.04. What is the difference between the Gross enrolment ratio (%) of Pre-primary schools in 1984 and the Gross enrolment ratio (%) of Primary schools in 1989?
Keep it short and to the point. -42.47. What is the difference between the Gross enrolment ratio (%) in Pre-primary schools in 1984 and the Gross enrolment ratio (%) in Secondary schools in 1989?
Offer a very short reply. -50.01. What is the difference between the Gross enrolment ratio (%) of Pre-primary schools in 1984 and the Gross enrolment ratio (%) of Tertiary schools in 1989?
Your response must be concise. 35.08. What is the difference between the Gross enrolment ratio (%) of Primary schools in 1984 and the Gross enrolment ratio (%) of Secondary schools in 1989?
Keep it short and to the point. -9.93. What is the difference between the Gross enrolment ratio (%) in Primary schools in 1984 and the Gross enrolment ratio (%) in Tertiary schools in 1989?
Provide a succinct answer. 75.16. What is the difference between the Gross enrolment ratio (%) in Secondary schools in 1984 and the Gross enrolment ratio (%) in Tertiary schools in 1989?
Ensure brevity in your answer.  68.86. What is the difference between the Gross enrolment ratio (%) in Pre-primary schools in 1984 and the Gross enrolment ratio (%) in Primary schools in 1990?
Your answer should be compact. -45.98. What is the difference between the Gross enrolment ratio (%) of Pre-primary schools in 1984 and the Gross enrolment ratio (%) of Secondary schools in 1990?
Offer a terse response. -50.12. What is the difference between the Gross enrolment ratio (%) in Pre-primary schools in 1984 and the Gross enrolment ratio (%) in Tertiary schools in 1990?
Provide a succinct answer. 32.55. What is the difference between the Gross enrolment ratio (%) in Primary schools in 1984 and the Gross enrolment ratio (%) in Secondary schools in 1990?
Offer a terse response. -10.03. What is the difference between the Gross enrolment ratio (%) of Primary schools in 1984 and the Gross enrolment ratio (%) of Tertiary schools in 1990?
Keep it short and to the point. 72.63. What is the difference between the Gross enrolment ratio (%) of Secondary schools in 1984 and the Gross enrolment ratio (%) of Tertiary schools in 1990?
Your answer should be compact. 66.33. What is the difference between the Gross enrolment ratio (%) of Pre-primary schools in 1985 and the Gross enrolment ratio (%) of Primary schools in 1986?
Your answer should be compact. -39.79. What is the difference between the Gross enrolment ratio (%) in Pre-primary schools in 1985 and the Gross enrolment ratio (%) in Secondary schools in 1986?
Offer a very short reply. -35.26. What is the difference between the Gross enrolment ratio (%) in Pre-primary schools in 1985 and the Gross enrolment ratio (%) in Tertiary schools in 1986?
Your answer should be very brief. 37.64. What is the difference between the Gross enrolment ratio (%) in Primary schools in 1985 and the Gross enrolment ratio (%) in Secondary schools in 1986?
Your answer should be very brief. 4.3. What is the difference between the Gross enrolment ratio (%) in Primary schools in 1985 and the Gross enrolment ratio (%) in Tertiary schools in 1986?
Provide a succinct answer. 77.2. What is the difference between the Gross enrolment ratio (%) of Secondary schools in 1985 and the Gross enrolment ratio (%) of Tertiary schools in 1986?
Your response must be concise. 71.97. What is the difference between the Gross enrolment ratio (%) of Pre-primary schools in 1985 and the Gross enrolment ratio (%) of Primary schools in 1987?
Your answer should be very brief. -38.76. What is the difference between the Gross enrolment ratio (%) in Pre-primary schools in 1985 and the Gross enrolment ratio (%) in Secondary schools in 1987?
Keep it short and to the point. -41.93. What is the difference between the Gross enrolment ratio (%) in Pre-primary schools in 1985 and the Gross enrolment ratio (%) in Tertiary schools in 1987?
Ensure brevity in your answer.  36.46. What is the difference between the Gross enrolment ratio (%) of Primary schools in 1985 and the Gross enrolment ratio (%) of Secondary schools in 1987?
Provide a short and direct response. -2.37. What is the difference between the Gross enrolment ratio (%) in Primary schools in 1985 and the Gross enrolment ratio (%) in Tertiary schools in 1987?
Give a very brief answer. 76.02. What is the difference between the Gross enrolment ratio (%) of Secondary schools in 1985 and the Gross enrolment ratio (%) of Tertiary schools in 1987?
Ensure brevity in your answer.  70.78. What is the difference between the Gross enrolment ratio (%) of Pre-primary schools in 1985 and the Gross enrolment ratio (%) of Primary schools in 1988?
Keep it short and to the point. -39.1. What is the difference between the Gross enrolment ratio (%) in Pre-primary schools in 1985 and the Gross enrolment ratio (%) in Secondary schools in 1988?
Keep it short and to the point. -43.84. What is the difference between the Gross enrolment ratio (%) of Pre-primary schools in 1985 and the Gross enrolment ratio (%) of Tertiary schools in 1988?
Make the answer very short. 36.43. What is the difference between the Gross enrolment ratio (%) of Primary schools in 1985 and the Gross enrolment ratio (%) of Secondary schools in 1988?
Your answer should be compact. -4.29. What is the difference between the Gross enrolment ratio (%) of Primary schools in 1985 and the Gross enrolment ratio (%) of Tertiary schools in 1988?
Your answer should be very brief. 75.99. What is the difference between the Gross enrolment ratio (%) in Secondary schools in 1985 and the Gross enrolment ratio (%) in Tertiary schools in 1988?
Provide a succinct answer. 70.76. What is the difference between the Gross enrolment ratio (%) in Pre-primary schools in 1985 and the Gross enrolment ratio (%) in Primary schools in 1989?
Give a very brief answer. -41.3. What is the difference between the Gross enrolment ratio (%) of Pre-primary schools in 1985 and the Gross enrolment ratio (%) of Secondary schools in 1989?
Make the answer very short. -48.84. What is the difference between the Gross enrolment ratio (%) of Pre-primary schools in 1985 and the Gross enrolment ratio (%) of Tertiary schools in 1989?
Give a very brief answer. 36.25. What is the difference between the Gross enrolment ratio (%) in Primary schools in 1985 and the Gross enrolment ratio (%) in Secondary schools in 1989?
Your answer should be compact. -9.28. What is the difference between the Gross enrolment ratio (%) in Primary schools in 1985 and the Gross enrolment ratio (%) in Tertiary schools in 1989?
Provide a short and direct response. 75.81. What is the difference between the Gross enrolment ratio (%) in Secondary schools in 1985 and the Gross enrolment ratio (%) in Tertiary schools in 1989?
Provide a short and direct response. 70.58. What is the difference between the Gross enrolment ratio (%) of Pre-primary schools in 1985 and the Gross enrolment ratio (%) of Primary schools in 1990?
Your answer should be very brief. -44.81. What is the difference between the Gross enrolment ratio (%) of Pre-primary schools in 1985 and the Gross enrolment ratio (%) of Secondary schools in 1990?
Your response must be concise. -48.95. What is the difference between the Gross enrolment ratio (%) of Pre-primary schools in 1985 and the Gross enrolment ratio (%) of Tertiary schools in 1990?
Your answer should be compact. 33.72. What is the difference between the Gross enrolment ratio (%) in Primary schools in 1985 and the Gross enrolment ratio (%) in Secondary schools in 1990?
Offer a very short reply. -9.39. What is the difference between the Gross enrolment ratio (%) of Primary schools in 1985 and the Gross enrolment ratio (%) of Tertiary schools in 1990?
Ensure brevity in your answer.  73.27. What is the difference between the Gross enrolment ratio (%) of Secondary schools in 1985 and the Gross enrolment ratio (%) of Tertiary schools in 1990?
Offer a terse response. 68.04. What is the difference between the Gross enrolment ratio (%) in Pre-primary schools in 1986 and the Gross enrolment ratio (%) in Primary schools in 1987?
Ensure brevity in your answer.  -42.01. What is the difference between the Gross enrolment ratio (%) of Pre-primary schools in 1986 and the Gross enrolment ratio (%) of Secondary schools in 1987?
Provide a short and direct response. -45.18. What is the difference between the Gross enrolment ratio (%) of Pre-primary schools in 1986 and the Gross enrolment ratio (%) of Tertiary schools in 1987?
Offer a very short reply. 33.2. What is the difference between the Gross enrolment ratio (%) of Primary schools in 1986 and the Gross enrolment ratio (%) of Secondary schools in 1987?
Keep it short and to the point. -2.14. What is the difference between the Gross enrolment ratio (%) of Primary schools in 1986 and the Gross enrolment ratio (%) of Tertiary schools in 1987?
Make the answer very short. 76.25. What is the difference between the Gross enrolment ratio (%) of Secondary schools in 1986 and the Gross enrolment ratio (%) of Tertiary schools in 1987?
Provide a succinct answer. 71.72. What is the difference between the Gross enrolment ratio (%) of Pre-primary schools in 1986 and the Gross enrolment ratio (%) of Primary schools in 1988?
Your answer should be compact. -42.36. What is the difference between the Gross enrolment ratio (%) in Pre-primary schools in 1986 and the Gross enrolment ratio (%) in Secondary schools in 1988?
Your response must be concise. -47.1. What is the difference between the Gross enrolment ratio (%) of Pre-primary schools in 1986 and the Gross enrolment ratio (%) of Tertiary schools in 1988?
Ensure brevity in your answer.  33.18. What is the difference between the Gross enrolment ratio (%) of Primary schools in 1986 and the Gross enrolment ratio (%) of Secondary schools in 1988?
Your answer should be compact. -4.05. What is the difference between the Gross enrolment ratio (%) of Primary schools in 1986 and the Gross enrolment ratio (%) of Tertiary schools in 1988?
Keep it short and to the point. 76.22. What is the difference between the Gross enrolment ratio (%) in Secondary schools in 1986 and the Gross enrolment ratio (%) in Tertiary schools in 1988?
Your answer should be compact. 71.69. What is the difference between the Gross enrolment ratio (%) in Pre-primary schools in 1986 and the Gross enrolment ratio (%) in Primary schools in 1989?
Keep it short and to the point. -44.55. What is the difference between the Gross enrolment ratio (%) in Pre-primary schools in 1986 and the Gross enrolment ratio (%) in Secondary schools in 1989?
Offer a terse response. -52.1. What is the difference between the Gross enrolment ratio (%) of Pre-primary schools in 1986 and the Gross enrolment ratio (%) of Tertiary schools in 1989?
Keep it short and to the point. 33. What is the difference between the Gross enrolment ratio (%) of Primary schools in 1986 and the Gross enrolment ratio (%) of Secondary schools in 1989?
Your response must be concise. -9.05. What is the difference between the Gross enrolment ratio (%) of Primary schools in 1986 and the Gross enrolment ratio (%) of Tertiary schools in 1989?
Keep it short and to the point. 76.04. What is the difference between the Gross enrolment ratio (%) of Secondary schools in 1986 and the Gross enrolment ratio (%) of Tertiary schools in 1989?
Offer a terse response. 71.51. What is the difference between the Gross enrolment ratio (%) of Pre-primary schools in 1986 and the Gross enrolment ratio (%) of Primary schools in 1990?
Your answer should be very brief. -48.06. What is the difference between the Gross enrolment ratio (%) of Pre-primary schools in 1986 and the Gross enrolment ratio (%) of Secondary schools in 1990?
Offer a terse response. -52.2. What is the difference between the Gross enrolment ratio (%) in Pre-primary schools in 1986 and the Gross enrolment ratio (%) in Tertiary schools in 1990?
Your answer should be compact. 30.46. What is the difference between the Gross enrolment ratio (%) of Primary schools in 1986 and the Gross enrolment ratio (%) of Secondary schools in 1990?
Ensure brevity in your answer.  -9.16. What is the difference between the Gross enrolment ratio (%) of Primary schools in 1986 and the Gross enrolment ratio (%) of Tertiary schools in 1990?
Provide a succinct answer. 73.51. What is the difference between the Gross enrolment ratio (%) in Secondary schools in 1986 and the Gross enrolment ratio (%) in Tertiary schools in 1990?
Give a very brief answer. 68.98. What is the difference between the Gross enrolment ratio (%) in Pre-primary schools in 1987 and the Gross enrolment ratio (%) in Primary schools in 1988?
Give a very brief answer. -40.56. What is the difference between the Gross enrolment ratio (%) in Pre-primary schools in 1987 and the Gross enrolment ratio (%) in Secondary schools in 1988?
Offer a terse response. -45.31. What is the difference between the Gross enrolment ratio (%) in Pre-primary schools in 1987 and the Gross enrolment ratio (%) in Tertiary schools in 1988?
Provide a short and direct response. 34.97. What is the difference between the Gross enrolment ratio (%) in Primary schools in 1987 and the Gross enrolment ratio (%) in Secondary schools in 1988?
Your answer should be compact. -5.09. What is the difference between the Gross enrolment ratio (%) in Primary schools in 1987 and the Gross enrolment ratio (%) in Tertiary schools in 1988?
Keep it short and to the point. 75.19. What is the difference between the Gross enrolment ratio (%) of Secondary schools in 1987 and the Gross enrolment ratio (%) of Tertiary schools in 1988?
Your answer should be compact. 78.36. What is the difference between the Gross enrolment ratio (%) of Pre-primary schools in 1987 and the Gross enrolment ratio (%) of Primary schools in 1989?
Your response must be concise. -42.76. What is the difference between the Gross enrolment ratio (%) of Pre-primary schools in 1987 and the Gross enrolment ratio (%) of Secondary schools in 1989?
Your response must be concise. -50.31. What is the difference between the Gross enrolment ratio (%) in Pre-primary schools in 1987 and the Gross enrolment ratio (%) in Tertiary schools in 1989?
Provide a short and direct response. 34.79. What is the difference between the Gross enrolment ratio (%) of Primary schools in 1987 and the Gross enrolment ratio (%) of Secondary schools in 1989?
Offer a terse response. -10.09. What is the difference between the Gross enrolment ratio (%) in Primary schools in 1987 and the Gross enrolment ratio (%) in Tertiary schools in 1989?
Provide a short and direct response. 75.01. What is the difference between the Gross enrolment ratio (%) of Secondary schools in 1987 and the Gross enrolment ratio (%) of Tertiary schools in 1989?
Offer a very short reply. 78.18. What is the difference between the Gross enrolment ratio (%) in Pre-primary schools in 1987 and the Gross enrolment ratio (%) in Primary schools in 1990?
Your response must be concise. -46.27. What is the difference between the Gross enrolment ratio (%) in Pre-primary schools in 1987 and the Gross enrolment ratio (%) in Secondary schools in 1990?
Provide a short and direct response. -50.41. What is the difference between the Gross enrolment ratio (%) in Pre-primary schools in 1987 and the Gross enrolment ratio (%) in Tertiary schools in 1990?
Your answer should be very brief. 32.25. What is the difference between the Gross enrolment ratio (%) of Primary schools in 1987 and the Gross enrolment ratio (%) of Secondary schools in 1990?
Provide a short and direct response. -10.19. What is the difference between the Gross enrolment ratio (%) in Primary schools in 1987 and the Gross enrolment ratio (%) in Tertiary schools in 1990?
Offer a terse response. 72.47. What is the difference between the Gross enrolment ratio (%) of Secondary schools in 1987 and the Gross enrolment ratio (%) of Tertiary schools in 1990?
Your response must be concise. 75.64. What is the difference between the Gross enrolment ratio (%) in Pre-primary schools in 1988 and the Gross enrolment ratio (%) in Primary schools in 1989?
Offer a very short reply. -39.73. What is the difference between the Gross enrolment ratio (%) of Pre-primary schools in 1988 and the Gross enrolment ratio (%) of Secondary schools in 1989?
Your response must be concise. -47.28. What is the difference between the Gross enrolment ratio (%) in Pre-primary schools in 1988 and the Gross enrolment ratio (%) in Tertiary schools in 1989?
Ensure brevity in your answer.  37.82. What is the difference between the Gross enrolment ratio (%) in Primary schools in 1988 and the Gross enrolment ratio (%) in Secondary schools in 1989?
Your answer should be compact. -9.74. What is the difference between the Gross enrolment ratio (%) of Primary schools in 1988 and the Gross enrolment ratio (%) of Tertiary schools in 1989?
Ensure brevity in your answer.  75.35. What is the difference between the Gross enrolment ratio (%) in Secondary schools in 1988 and the Gross enrolment ratio (%) in Tertiary schools in 1989?
Give a very brief answer. 80.09. What is the difference between the Gross enrolment ratio (%) of Pre-primary schools in 1988 and the Gross enrolment ratio (%) of Primary schools in 1990?
Your answer should be compact. -43.24. What is the difference between the Gross enrolment ratio (%) in Pre-primary schools in 1988 and the Gross enrolment ratio (%) in Secondary schools in 1990?
Keep it short and to the point. -47.38. What is the difference between the Gross enrolment ratio (%) in Pre-primary schools in 1988 and the Gross enrolment ratio (%) in Tertiary schools in 1990?
Your answer should be compact. 35.28. What is the difference between the Gross enrolment ratio (%) of Primary schools in 1988 and the Gross enrolment ratio (%) of Secondary schools in 1990?
Make the answer very short. -9.85. What is the difference between the Gross enrolment ratio (%) of Primary schools in 1988 and the Gross enrolment ratio (%) of Tertiary schools in 1990?
Provide a short and direct response. 72.82. What is the difference between the Gross enrolment ratio (%) in Secondary schools in 1988 and the Gross enrolment ratio (%) in Tertiary schools in 1990?
Provide a short and direct response. 77.56. What is the difference between the Gross enrolment ratio (%) in Pre-primary schools in 1989 and the Gross enrolment ratio (%) in Primary schools in 1990?
Offer a terse response. -43.35. What is the difference between the Gross enrolment ratio (%) in Pre-primary schools in 1989 and the Gross enrolment ratio (%) in Secondary schools in 1990?
Offer a very short reply. -47.49. What is the difference between the Gross enrolment ratio (%) of Pre-primary schools in 1989 and the Gross enrolment ratio (%) of Tertiary schools in 1990?
Your answer should be compact. 35.18. What is the difference between the Gross enrolment ratio (%) of Primary schools in 1989 and the Gross enrolment ratio (%) of Secondary schools in 1990?
Offer a very short reply. -7.65. What is the difference between the Gross enrolment ratio (%) in Primary schools in 1989 and the Gross enrolment ratio (%) in Tertiary schools in 1990?
Provide a succinct answer. 75.01. What is the difference between the Gross enrolment ratio (%) in Secondary schools in 1989 and the Gross enrolment ratio (%) in Tertiary schools in 1990?
Offer a very short reply. 82.56. What is the average Gross enrolment ratio (%) in Pre-primary schools per year?
Your answer should be very brief. 58.08. What is the average Gross enrolment ratio (%) of Primary schools per year?
Provide a short and direct response. 98.22. What is the average Gross enrolment ratio (%) in Secondary schools per year?
Offer a terse response. 97.51. What is the average Gross enrolment ratio (%) of Tertiary schools per year?
Ensure brevity in your answer.  21.07. In the year 1982, what is the difference between the Gross enrolment ratio (%) of Pre-primary schools and Gross enrolment ratio (%) of Primary schools?
Give a very brief answer. -38.66. In the year 1982, what is the difference between the Gross enrolment ratio (%) in Pre-primary schools and Gross enrolment ratio (%) in Secondary schools?
Make the answer very short. -34.05. In the year 1982, what is the difference between the Gross enrolment ratio (%) in Pre-primary schools and Gross enrolment ratio (%) in Tertiary schools?
Ensure brevity in your answer.  36.1. In the year 1982, what is the difference between the Gross enrolment ratio (%) of Primary schools and Gross enrolment ratio (%) of Secondary schools?
Make the answer very short. 4.61. In the year 1982, what is the difference between the Gross enrolment ratio (%) in Primary schools and Gross enrolment ratio (%) in Tertiary schools?
Make the answer very short. 74.76. In the year 1982, what is the difference between the Gross enrolment ratio (%) of Secondary schools and Gross enrolment ratio (%) of Tertiary schools?
Your answer should be very brief. 70.15. In the year 1983, what is the difference between the Gross enrolment ratio (%) in Pre-primary schools and Gross enrolment ratio (%) in Primary schools?
Ensure brevity in your answer.  -39.55. In the year 1983, what is the difference between the Gross enrolment ratio (%) of Pre-primary schools and Gross enrolment ratio (%) of Secondary schools?
Offer a very short reply. -34.21. In the year 1983, what is the difference between the Gross enrolment ratio (%) in Pre-primary schools and Gross enrolment ratio (%) in Tertiary schools?
Your response must be concise. 38.04. In the year 1983, what is the difference between the Gross enrolment ratio (%) in Primary schools and Gross enrolment ratio (%) in Secondary schools?
Make the answer very short. 5.35. In the year 1983, what is the difference between the Gross enrolment ratio (%) in Primary schools and Gross enrolment ratio (%) in Tertiary schools?
Make the answer very short. 77.6. In the year 1983, what is the difference between the Gross enrolment ratio (%) of Secondary schools and Gross enrolment ratio (%) of Tertiary schools?
Your answer should be very brief. 72.25. In the year 1984, what is the difference between the Gross enrolment ratio (%) in Pre-primary schools and Gross enrolment ratio (%) in Primary schools?
Your answer should be compact. -40.08. In the year 1984, what is the difference between the Gross enrolment ratio (%) of Pre-primary schools and Gross enrolment ratio (%) of Secondary schools?
Make the answer very short. -33.78. In the year 1984, what is the difference between the Gross enrolment ratio (%) in Pre-primary schools and Gross enrolment ratio (%) in Tertiary schools?
Provide a succinct answer. 38.66. In the year 1984, what is the difference between the Gross enrolment ratio (%) of Primary schools and Gross enrolment ratio (%) of Secondary schools?
Give a very brief answer. 6.3. In the year 1984, what is the difference between the Gross enrolment ratio (%) of Primary schools and Gross enrolment ratio (%) of Tertiary schools?
Provide a short and direct response. 78.74. In the year 1984, what is the difference between the Gross enrolment ratio (%) of Secondary schools and Gross enrolment ratio (%) of Tertiary schools?
Make the answer very short. 72.44. In the year 1985, what is the difference between the Gross enrolment ratio (%) of Pre-primary schools and Gross enrolment ratio (%) of Primary schools?
Make the answer very short. -39.56. In the year 1985, what is the difference between the Gross enrolment ratio (%) of Pre-primary schools and Gross enrolment ratio (%) of Secondary schools?
Provide a succinct answer. -34.33. In the year 1985, what is the difference between the Gross enrolment ratio (%) of Pre-primary schools and Gross enrolment ratio (%) of Tertiary schools?
Provide a succinct answer. 39.49. In the year 1985, what is the difference between the Gross enrolment ratio (%) in Primary schools and Gross enrolment ratio (%) in Secondary schools?
Provide a succinct answer. 5.23. In the year 1985, what is the difference between the Gross enrolment ratio (%) of Primary schools and Gross enrolment ratio (%) of Tertiary schools?
Make the answer very short. 79.05. In the year 1985, what is the difference between the Gross enrolment ratio (%) of Secondary schools and Gross enrolment ratio (%) of Tertiary schools?
Your answer should be compact. 73.82. In the year 1986, what is the difference between the Gross enrolment ratio (%) in Pre-primary schools and Gross enrolment ratio (%) in Primary schools?
Your answer should be very brief. -43.04. In the year 1986, what is the difference between the Gross enrolment ratio (%) of Pre-primary schools and Gross enrolment ratio (%) of Secondary schools?
Make the answer very short. -38.51. In the year 1986, what is the difference between the Gross enrolment ratio (%) of Pre-primary schools and Gross enrolment ratio (%) of Tertiary schools?
Provide a short and direct response. 34.39. In the year 1986, what is the difference between the Gross enrolment ratio (%) in Primary schools and Gross enrolment ratio (%) in Secondary schools?
Offer a very short reply. 4.53. In the year 1986, what is the difference between the Gross enrolment ratio (%) of Primary schools and Gross enrolment ratio (%) of Tertiary schools?
Your response must be concise. 77.43. In the year 1986, what is the difference between the Gross enrolment ratio (%) in Secondary schools and Gross enrolment ratio (%) in Tertiary schools?
Keep it short and to the point. 72.9. In the year 1987, what is the difference between the Gross enrolment ratio (%) of Pre-primary schools and Gross enrolment ratio (%) of Primary schools?
Provide a short and direct response. -40.22. In the year 1987, what is the difference between the Gross enrolment ratio (%) of Pre-primary schools and Gross enrolment ratio (%) of Secondary schools?
Your answer should be very brief. -43.39. In the year 1987, what is the difference between the Gross enrolment ratio (%) in Pre-primary schools and Gross enrolment ratio (%) in Tertiary schools?
Your answer should be compact. 34.99. In the year 1987, what is the difference between the Gross enrolment ratio (%) of Primary schools and Gross enrolment ratio (%) of Secondary schools?
Offer a terse response. -3.17. In the year 1987, what is the difference between the Gross enrolment ratio (%) in Primary schools and Gross enrolment ratio (%) in Tertiary schools?
Keep it short and to the point. 75.21. In the year 1987, what is the difference between the Gross enrolment ratio (%) of Secondary schools and Gross enrolment ratio (%) of Tertiary schools?
Provide a short and direct response. 78.38. In the year 1988, what is the difference between the Gross enrolment ratio (%) of Pre-primary schools and Gross enrolment ratio (%) of Primary schools?
Keep it short and to the point. -37.54. In the year 1988, what is the difference between the Gross enrolment ratio (%) in Pre-primary schools and Gross enrolment ratio (%) in Secondary schools?
Your answer should be compact. -42.28. In the year 1988, what is the difference between the Gross enrolment ratio (%) of Pre-primary schools and Gross enrolment ratio (%) of Tertiary schools?
Make the answer very short. 38. In the year 1988, what is the difference between the Gross enrolment ratio (%) in Primary schools and Gross enrolment ratio (%) in Secondary schools?
Your answer should be very brief. -4.74. In the year 1988, what is the difference between the Gross enrolment ratio (%) of Primary schools and Gross enrolment ratio (%) of Tertiary schools?
Offer a very short reply. 75.53. In the year 1988, what is the difference between the Gross enrolment ratio (%) in Secondary schools and Gross enrolment ratio (%) in Tertiary schools?
Offer a very short reply. 80.28. In the year 1989, what is the difference between the Gross enrolment ratio (%) of Pre-primary schools and Gross enrolment ratio (%) of Primary schools?
Your answer should be compact. -39.83. In the year 1989, what is the difference between the Gross enrolment ratio (%) of Pre-primary schools and Gross enrolment ratio (%) of Secondary schools?
Offer a terse response. -47.38. In the year 1989, what is the difference between the Gross enrolment ratio (%) in Pre-primary schools and Gross enrolment ratio (%) in Tertiary schools?
Ensure brevity in your answer.  37.71. In the year 1989, what is the difference between the Gross enrolment ratio (%) of Primary schools and Gross enrolment ratio (%) of Secondary schools?
Your response must be concise. -7.55. In the year 1989, what is the difference between the Gross enrolment ratio (%) in Primary schools and Gross enrolment ratio (%) in Tertiary schools?
Keep it short and to the point. 77.55. In the year 1989, what is the difference between the Gross enrolment ratio (%) of Secondary schools and Gross enrolment ratio (%) of Tertiary schools?
Keep it short and to the point. 85.09. In the year 1990, what is the difference between the Gross enrolment ratio (%) of Pre-primary schools and Gross enrolment ratio (%) of Primary schools?
Provide a short and direct response. -42.79. In the year 1990, what is the difference between the Gross enrolment ratio (%) in Pre-primary schools and Gross enrolment ratio (%) in Secondary schools?
Your response must be concise. -46.93. In the year 1990, what is the difference between the Gross enrolment ratio (%) of Pre-primary schools and Gross enrolment ratio (%) of Tertiary schools?
Make the answer very short. 35.73. In the year 1990, what is the difference between the Gross enrolment ratio (%) of Primary schools and Gross enrolment ratio (%) of Secondary schools?
Give a very brief answer. -4.14. In the year 1990, what is the difference between the Gross enrolment ratio (%) in Primary schools and Gross enrolment ratio (%) in Tertiary schools?
Ensure brevity in your answer.  78.52. In the year 1990, what is the difference between the Gross enrolment ratio (%) of Secondary schools and Gross enrolment ratio (%) of Tertiary schools?
Ensure brevity in your answer.  82.66. What is the ratio of the Gross enrolment ratio (%) in Pre-primary schools in 1982 to that in 1983?
Your answer should be very brief. 0.98. What is the ratio of the Gross enrolment ratio (%) of Primary schools in 1982 to that in 1983?
Ensure brevity in your answer.  0.98. What is the ratio of the Gross enrolment ratio (%) in Secondary schools in 1982 to that in 1983?
Provide a succinct answer. 0.98. What is the ratio of the Gross enrolment ratio (%) in Tertiary schools in 1982 to that in 1983?
Provide a short and direct response. 1.03. What is the ratio of the Gross enrolment ratio (%) of Pre-primary schools in 1982 to that in 1984?
Provide a succinct answer. 0.97. What is the ratio of the Gross enrolment ratio (%) of Primary schools in 1982 to that in 1984?
Your response must be concise. 0.96. What is the ratio of the Gross enrolment ratio (%) of Secondary schools in 1982 to that in 1984?
Your response must be concise. 0.98. What is the ratio of the Gross enrolment ratio (%) of Tertiary schools in 1982 to that in 1984?
Ensure brevity in your answer.  1.03. What is the ratio of the Gross enrolment ratio (%) in Pre-primary schools in 1982 to that in 1985?
Your response must be concise. 0.95. What is the ratio of the Gross enrolment ratio (%) of Primary schools in 1982 to that in 1985?
Give a very brief answer. 0.96. What is the ratio of the Gross enrolment ratio (%) in Secondary schools in 1982 to that in 1985?
Ensure brevity in your answer.  0.96. What is the ratio of the Gross enrolment ratio (%) in Tertiary schools in 1982 to that in 1985?
Provide a succinct answer. 1.01. What is the ratio of the Gross enrolment ratio (%) of Pre-primary schools in 1982 to that in 1986?
Ensure brevity in your answer.  1. What is the ratio of the Gross enrolment ratio (%) in Primary schools in 1982 to that in 1986?
Make the answer very short. 0.96. What is the ratio of the Gross enrolment ratio (%) of Secondary schools in 1982 to that in 1986?
Your response must be concise. 0.95. What is the ratio of the Gross enrolment ratio (%) of Tertiary schools in 1982 to that in 1986?
Ensure brevity in your answer.  0.92. What is the ratio of the Gross enrolment ratio (%) of Pre-primary schools in 1982 to that in 1987?
Your answer should be compact. 0.97. What is the ratio of the Gross enrolment ratio (%) of Primary schools in 1982 to that in 1987?
Provide a succinct answer. 0.97. What is the ratio of the Gross enrolment ratio (%) of Secondary schools in 1982 to that in 1987?
Provide a succinct answer. 0.89. What is the ratio of the Gross enrolment ratio (%) in Tertiary schools in 1982 to that in 1987?
Give a very brief answer. 0.87. What is the ratio of the Gross enrolment ratio (%) of Pre-primary schools in 1982 to that in 1988?
Provide a succinct answer. 0.92. What is the ratio of the Gross enrolment ratio (%) of Secondary schools in 1982 to that in 1988?
Provide a succinct answer. 0.87. What is the ratio of the Gross enrolment ratio (%) in Tertiary schools in 1982 to that in 1988?
Your answer should be very brief. 0.87. What is the ratio of the Gross enrolment ratio (%) of Pre-primary schools in 1982 to that in 1989?
Your answer should be compact. 0.92. What is the ratio of the Gross enrolment ratio (%) of Primary schools in 1982 to that in 1989?
Your response must be concise. 0.94. What is the ratio of the Gross enrolment ratio (%) of Secondary schools in 1982 to that in 1989?
Your answer should be compact. 0.83. What is the ratio of the Gross enrolment ratio (%) in Tertiary schools in 1982 to that in 1989?
Keep it short and to the point. 0.87. What is the ratio of the Gross enrolment ratio (%) of Pre-primary schools in 1982 to that in 1990?
Make the answer very short. 0.91. What is the ratio of the Gross enrolment ratio (%) of Primary schools in 1982 to that in 1990?
Provide a succinct answer. 0.91. What is the ratio of the Gross enrolment ratio (%) of Secondary schools in 1982 to that in 1990?
Give a very brief answer. 0.83. What is the ratio of the Gross enrolment ratio (%) in Tertiary schools in 1982 to that in 1990?
Offer a terse response. 0.78. What is the ratio of the Gross enrolment ratio (%) of Pre-primary schools in 1983 to that in 1984?
Give a very brief answer. 0.99. What is the ratio of the Gross enrolment ratio (%) in Primary schools in 1983 to that in 1984?
Ensure brevity in your answer.  0.99. What is the ratio of the Gross enrolment ratio (%) in Secondary schools in 1983 to that in 1984?
Provide a succinct answer. 1. What is the ratio of the Gross enrolment ratio (%) of Pre-primary schools in 1983 to that in 1985?
Provide a short and direct response. 0.97. What is the ratio of the Gross enrolment ratio (%) of Primary schools in 1983 to that in 1985?
Your answer should be very brief. 0.98. What is the ratio of the Gross enrolment ratio (%) of Secondary schools in 1983 to that in 1985?
Your response must be concise. 0.98. What is the ratio of the Gross enrolment ratio (%) of Tertiary schools in 1983 to that in 1985?
Make the answer very short. 0.98. What is the ratio of the Gross enrolment ratio (%) in Pre-primary schools in 1983 to that in 1986?
Ensure brevity in your answer.  1.03. What is the ratio of the Gross enrolment ratio (%) of Primary schools in 1983 to that in 1986?
Give a very brief answer. 0.98. What is the ratio of the Gross enrolment ratio (%) in Secondary schools in 1983 to that in 1986?
Keep it short and to the point. 0.97. What is the ratio of the Gross enrolment ratio (%) of Tertiary schools in 1983 to that in 1986?
Your response must be concise. 0.9. What is the ratio of the Gross enrolment ratio (%) of Pre-primary schools in 1983 to that in 1987?
Ensure brevity in your answer.  0.99. What is the ratio of the Gross enrolment ratio (%) of Secondary schools in 1983 to that in 1987?
Ensure brevity in your answer.  0.91. What is the ratio of the Gross enrolment ratio (%) of Tertiary schools in 1983 to that in 1987?
Provide a short and direct response. 0.85. What is the ratio of the Gross enrolment ratio (%) of Primary schools in 1983 to that in 1988?
Provide a succinct answer. 0.99. What is the ratio of the Gross enrolment ratio (%) in Secondary schools in 1983 to that in 1988?
Provide a succinct answer. 0.89. What is the ratio of the Gross enrolment ratio (%) of Tertiary schools in 1983 to that in 1988?
Your answer should be very brief. 0.85. What is the ratio of the Gross enrolment ratio (%) in Pre-primary schools in 1983 to that in 1989?
Your response must be concise. 0.95. What is the ratio of the Gross enrolment ratio (%) of Primary schools in 1983 to that in 1989?
Your answer should be compact. 0.96. What is the ratio of the Gross enrolment ratio (%) of Secondary schools in 1983 to that in 1989?
Your response must be concise. 0.85. What is the ratio of the Gross enrolment ratio (%) in Tertiary schools in 1983 to that in 1989?
Offer a terse response. 0.84. What is the ratio of the Gross enrolment ratio (%) of Pre-primary schools in 1983 to that in 1990?
Provide a short and direct response. 0.94. What is the ratio of the Gross enrolment ratio (%) in Primary schools in 1983 to that in 1990?
Offer a terse response. 0.93. What is the ratio of the Gross enrolment ratio (%) of Secondary schools in 1983 to that in 1990?
Your answer should be very brief. 0.85. What is the ratio of the Gross enrolment ratio (%) of Tertiary schools in 1983 to that in 1990?
Your answer should be compact. 0.76. What is the ratio of the Gross enrolment ratio (%) of Pre-primary schools in 1984 to that in 1985?
Your response must be concise. 0.98. What is the ratio of the Gross enrolment ratio (%) in Secondary schools in 1984 to that in 1985?
Give a very brief answer. 0.98. What is the ratio of the Gross enrolment ratio (%) of Tertiary schools in 1984 to that in 1985?
Keep it short and to the point. 0.98. What is the ratio of the Gross enrolment ratio (%) of Pre-primary schools in 1984 to that in 1986?
Offer a terse response. 1.04. What is the ratio of the Gross enrolment ratio (%) of Secondary schools in 1984 to that in 1986?
Provide a short and direct response. 0.97. What is the ratio of the Gross enrolment ratio (%) in Tertiary schools in 1984 to that in 1986?
Give a very brief answer. 0.9. What is the ratio of the Gross enrolment ratio (%) in Primary schools in 1984 to that in 1987?
Your answer should be very brief. 1. What is the ratio of the Gross enrolment ratio (%) in Secondary schools in 1984 to that in 1987?
Provide a succinct answer. 0.91. What is the ratio of the Gross enrolment ratio (%) of Tertiary schools in 1984 to that in 1987?
Your answer should be compact. 0.85. What is the ratio of the Gross enrolment ratio (%) of Pre-primary schools in 1984 to that in 1988?
Give a very brief answer. 0.95. What is the ratio of the Gross enrolment ratio (%) in Secondary schools in 1984 to that in 1988?
Give a very brief answer. 0.89. What is the ratio of the Gross enrolment ratio (%) of Tertiary schools in 1984 to that in 1988?
Your response must be concise. 0.85. What is the ratio of the Gross enrolment ratio (%) in Pre-primary schools in 1984 to that in 1989?
Ensure brevity in your answer.  0.96. What is the ratio of the Gross enrolment ratio (%) of Primary schools in 1984 to that in 1989?
Provide a succinct answer. 0.98. What is the ratio of the Gross enrolment ratio (%) in Secondary schools in 1984 to that in 1989?
Offer a terse response. 0.85. What is the ratio of the Gross enrolment ratio (%) in Tertiary schools in 1984 to that in 1989?
Make the answer very short. 0.84. What is the ratio of the Gross enrolment ratio (%) of Pre-primary schools in 1984 to that in 1990?
Provide a short and direct response. 0.95. What is the ratio of the Gross enrolment ratio (%) of Primary schools in 1984 to that in 1990?
Provide a succinct answer. 0.94. What is the ratio of the Gross enrolment ratio (%) of Secondary schools in 1984 to that in 1990?
Make the answer very short. 0.85. What is the ratio of the Gross enrolment ratio (%) of Tertiary schools in 1984 to that in 1990?
Ensure brevity in your answer.  0.76. What is the ratio of the Gross enrolment ratio (%) in Pre-primary schools in 1985 to that in 1986?
Offer a terse response. 1.06. What is the ratio of the Gross enrolment ratio (%) in Primary schools in 1985 to that in 1986?
Your response must be concise. 1. What is the ratio of the Gross enrolment ratio (%) in Tertiary schools in 1985 to that in 1986?
Provide a succinct answer. 0.91. What is the ratio of the Gross enrolment ratio (%) in Pre-primary schools in 1985 to that in 1987?
Provide a succinct answer. 1.03. What is the ratio of the Gross enrolment ratio (%) of Primary schools in 1985 to that in 1987?
Your answer should be compact. 1.01. What is the ratio of the Gross enrolment ratio (%) in Secondary schools in 1985 to that in 1987?
Offer a terse response. 0.92. What is the ratio of the Gross enrolment ratio (%) of Tertiary schools in 1985 to that in 1987?
Make the answer very short. 0.86. What is the ratio of the Gross enrolment ratio (%) in Pre-primary schools in 1985 to that in 1988?
Offer a very short reply. 0.97. What is the ratio of the Gross enrolment ratio (%) of Secondary schools in 1985 to that in 1988?
Your answer should be compact. 0.91. What is the ratio of the Gross enrolment ratio (%) in Tertiary schools in 1985 to that in 1988?
Give a very brief answer. 0.86. What is the ratio of the Gross enrolment ratio (%) of Pre-primary schools in 1985 to that in 1989?
Provide a short and direct response. 0.98. What is the ratio of the Gross enrolment ratio (%) of Primary schools in 1985 to that in 1989?
Provide a succinct answer. 0.98. What is the ratio of the Gross enrolment ratio (%) of Secondary schools in 1985 to that in 1989?
Give a very brief answer. 0.87. What is the ratio of the Gross enrolment ratio (%) of Tertiary schools in 1985 to that in 1989?
Offer a terse response. 0.86. What is the ratio of the Gross enrolment ratio (%) of Pre-primary schools in 1985 to that in 1990?
Ensure brevity in your answer.  0.97. What is the ratio of the Gross enrolment ratio (%) of Primary schools in 1985 to that in 1990?
Your answer should be very brief. 0.95. What is the ratio of the Gross enrolment ratio (%) of Secondary schools in 1985 to that in 1990?
Ensure brevity in your answer.  0.86. What is the ratio of the Gross enrolment ratio (%) of Tertiary schools in 1985 to that in 1990?
Your answer should be very brief. 0.77. What is the ratio of the Gross enrolment ratio (%) of Pre-primary schools in 1986 to that in 1987?
Ensure brevity in your answer.  0.97. What is the ratio of the Gross enrolment ratio (%) in Primary schools in 1986 to that in 1987?
Keep it short and to the point. 1.01. What is the ratio of the Gross enrolment ratio (%) of Secondary schools in 1986 to that in 1987?
Your response must be concise. 0.93. What is the ratio of the Gross enrolment ratio (%) of Tertiary schools in 1986 to that in 1987?
Ensure brevity in your answer.  0.95. What is the ratio of the Gross enrolment ratio (%) in Pre-primary schools in 1986 to that in 1988?
Offer a terse response. 0.92. What is the ratio of the Gross enrolment ratio (%) in Secondary schools in 1986 to that in 1988?
Keep it short and to the point. 0.92. What is the ratio of the Gross enrolment ratio (%) of Tertiary schools in 1986 to that in 1988?
Keep it short and to the point. 0.95. What is the ratio of the Gross enrolment ratio (%) of Pre-primary schools in 1986 to that in 1989?
Ensure brevity in your answer.  0.92. What is the ratio of the Gross enrolment ratio (%) of Primary schools in 1986 to that in 1989?
Offer a terse response. 0.98. What is the ratio of the Gross enrolment ratio (%) of Secondary schools in 1986 to that in 1989?
Offer a very short reply. 0.87. What is the ratio of the Gross enrolment ratio (%) of Tertiary schools in 1986 to that in 1989?
Keep it short and to the point. 0.94. What is the ratio of the Gross enrolment ratio (%) in Pre-primary schools in 1986 to that in 1990?
Your answer should be compact. 0.91. What is the ratio of the Gross enrolment ratio (%) in Primary schools in 1986 to that in 1990?
Your answer should be compact. 0.95. What is the ratio of the Gross enrolment ratio (%) in Secondary schools in 1986 to that in 1990?
Provide a succinct answer. 0.87. What is the ratio of the Gross enrolment ratio (%) of Tertiary schools in 1986 to that in 1990?
Offer a terse response. 0.84. What is the ratio of the Gross enrolment ratio (%) of Pre-primary schools in 1987 to that in 1988?
Your response must be concise. 0.95. What is the ratio of the Gross enrolment ratio (%) of Primary schools in 1987 to that in 1988?
Your response must be concise. 1. What is the ratio of the Gross enrolment ratio (%) of Secondary schools in 1987 to that in 1988?
Your answer should be compact. 0.98. What is the ratio of the Gross enrolment ratio (%) in Pre-primary schools in 1987 to that in 1989?
Keep it short and to the point. 0.95. What is the ratio of the Gross enrolment ratio (%) in Primary schools in 1987 to that in 1989?
Keep it short and to the point. 0.97. What is the ratio of the Gross enrolment ratio (%) of Secondary schools in 1987 to that in 1989?
Keep it short and to the point. 0.94. What is the ratio of the Gross enrolment ratio (%) in Tertiary schools in 1987 to that in 1989?
Your answer should be compact. 0.99. What is the ratio of the Gross enrolment ratio (%) of Pre-primary schools in 1987 to that in 1990?
Your answer should be compact. 0.94. What is the ratio of the Gross enrolment ratio (%) of Primary schools in 1987 to that in 1990?
Your answer should be very brief. 0.94. What is the ratio of the Gross enrolment ratio (%) of Secondary schools in 1987 to that in 1990?
Your response must be concise. 0.93. What is the ratio of the Gross enrolment ratio (%) of Tertiary schools in 1987 to that in 1990?
Give a very brief answer. 0.89. What is the ratio of the Gross enrolment ratio (%) of Primary schools in 1988 to that in 1989?
Provide a succinct answer. 0.98. What is the ratio of the Gross enrolment ratio (%) of Secondary schools in 1988 to that in 1989?
Your response must be concise. 0.95. What is the ratio of the Gross enrolment ratio (%) in Tertiary schools in 1988 to that in 1989?
Give a very brief answer. 0.99. What is the ratio of the Gross enrolment ratio (%) of Primary schools in 1988 to that in 1990?
Keep it short and to the point. 0.94. What is the ratio of the Gross enrolment ratio (%) in Secondary schools in 1988 to that in 1990?
Provide a succinct answer. 0.95. What is the ratio of the Gross enrolment ratio (%) of Tertiary schools in 1988 to that in 1990?
Your response must be concise. 0.89. What is the ratio of the Gross enrolment ratio (%) in Primary schools in 1989 to that in 1990?
Your response must be concise. 0.97. What is the ratio of the Gross enrolment ratio (%) of Tertiary schools in 1989 to that in 1990?
Your answer should be very brief. 0.9. What is the difference between the highest and the second highest Gross enrolment ratio (%) of Pre-primary schools?
Offer a terse response. 0.45. What is the difference between the highest and the second highest Gross enrolment ratio (%) of Primary schools?
Ensure brevity in your answer.  3.51. What is the difference between the highest and the second highest Gross enrolment ratio (%) of Secondary schools?
Your response must be concise. 0.1. What is the difference between the highest and the second highest Gross enrolment ratio (%) in Tertiary schools?
Make the answer very short. 2.53. What is the difference between the highest and the lowest Gross enrolment ratio (%) in Pre-primary schools?
Offer a very short reply. 5.27. What is the difference between the highest and the lowest Gross enrolment ratio (%) of Primary schools?
Provide a short and direct response. 9.32. What is the difference between the highest and the lowest Gross enrolment ratio (%) in Secondary schools?
Provide a succinct answer. 18.07. What is the difference between the highest and the lowest Gross enrolment ratio (%) in Tertiary schools?
Provide a short and direct response. 6.12. 